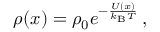<formula> <loc_0><loc_0><loc_500><loc_500>\rho ( x ) = \rho _ { 0 } e ^ { - \frac { U ( x ) } { k _ { B } T } } \, ,</formula> 